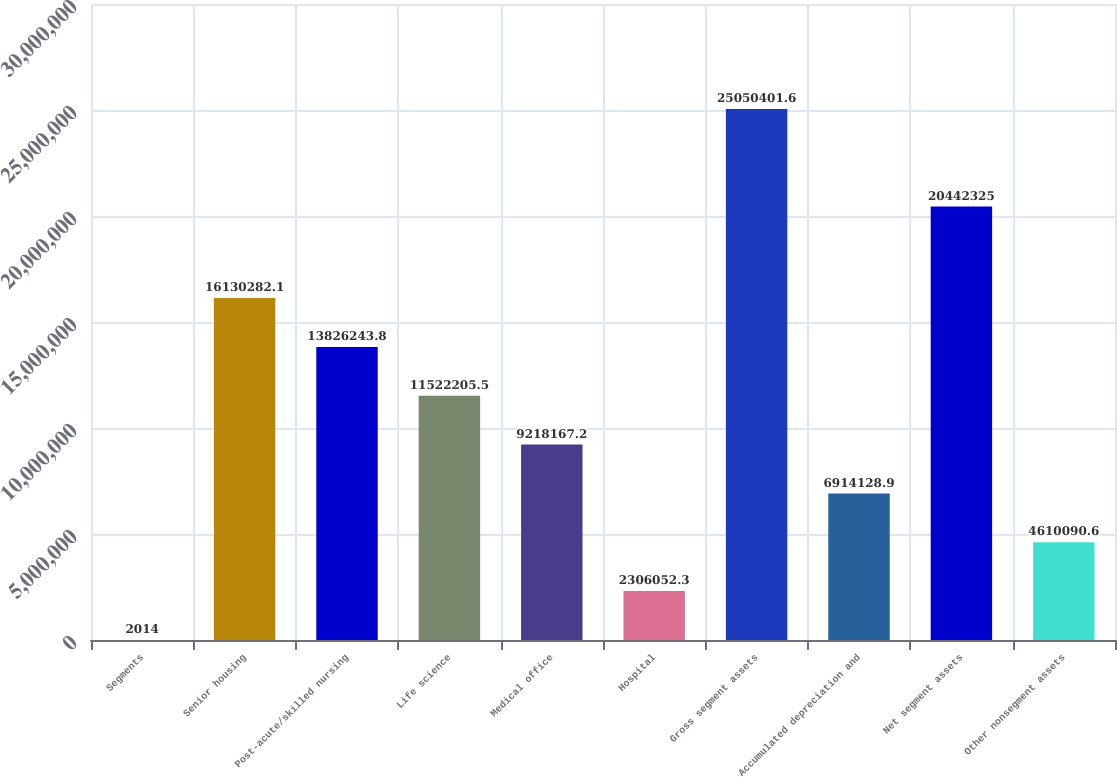<chart> <loc_0><loc_0><loc_500><loc_500><bar_chart><fcel>Segments<fcel>Senior housing<fcel>Post-acute/skilled nursing<fcel>Life science<fcel>Medical office<fcel>Hospital<fcel>Gross segment assets<fcel>Accumulated depreciation and<fcel>Net segment assets<fcel>Other nonsegment assets<nl><fcel>2014<fcel>1.61303e+07<fcel>1.38262e+07<fcel>1.15222e+07<fcel>9.21817e+06<fcel>2.30605e+06<fcel>2.50504e+07<fcel>6.91413e+06<fcel>2.04423e+07<fcel>4.61009e+06<nl></chart> 